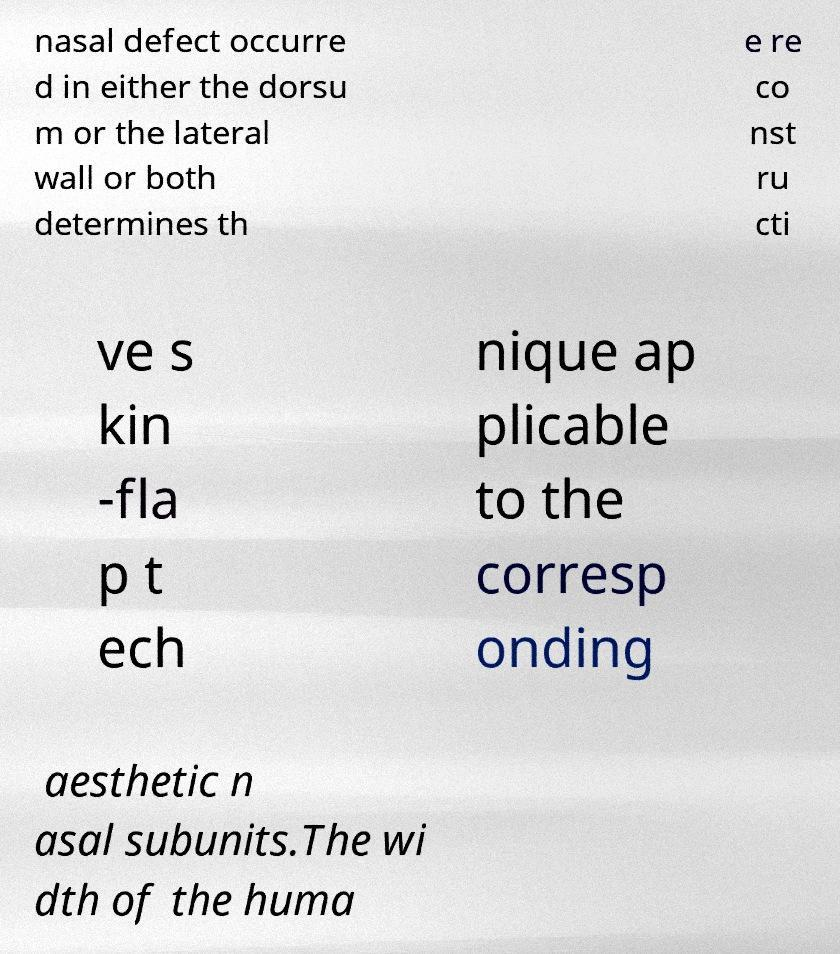I need the written content from this picture converted into text. Can you do that? nasal defect occurre d in either the dorsu m or the lateral wall or both determines th e re co nst ru cti ve s kin -fla p t ech nique ap plicable to the corresp onding aesthetic n asal subunits.The wi dth of the huma 